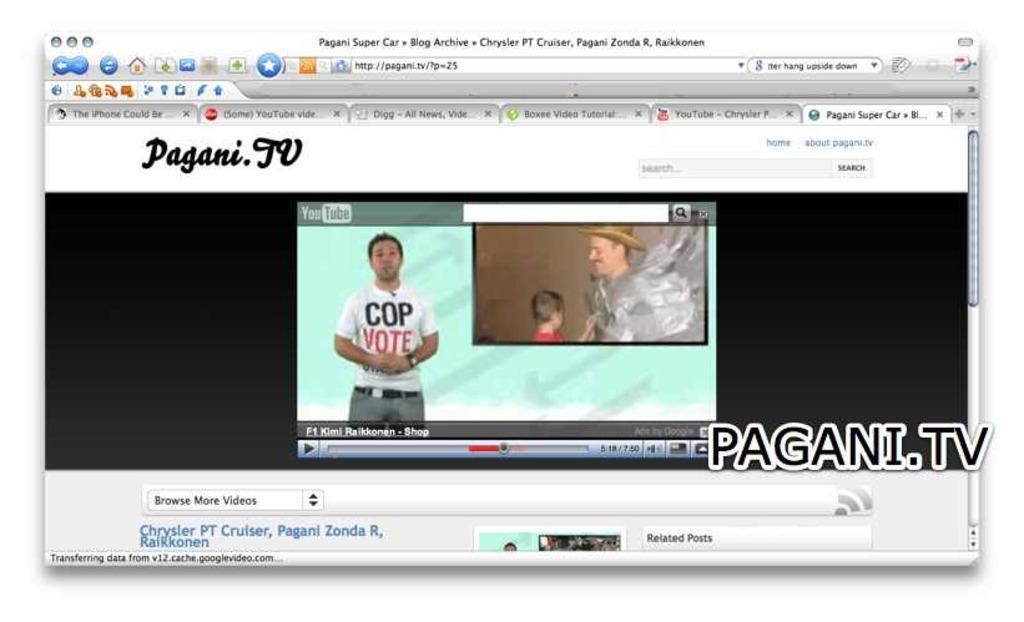Could you give a brief overview of what you see in this image? In the image it is a screenshot of a screen and it has a website page and different options, there is a video being displayed in the website. 